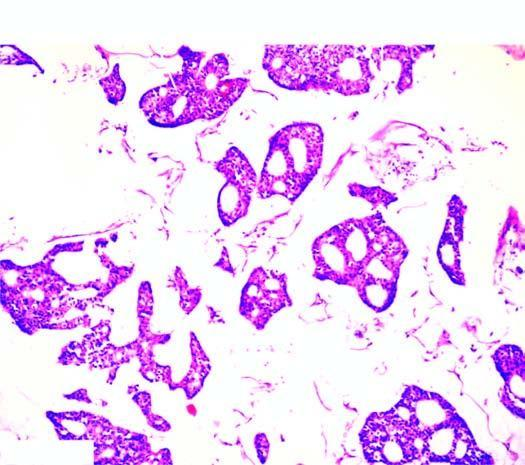what are the tumour cells seen as?
Answer the question using a single word or phrase. Clusters floating in pools of abundant mucin 